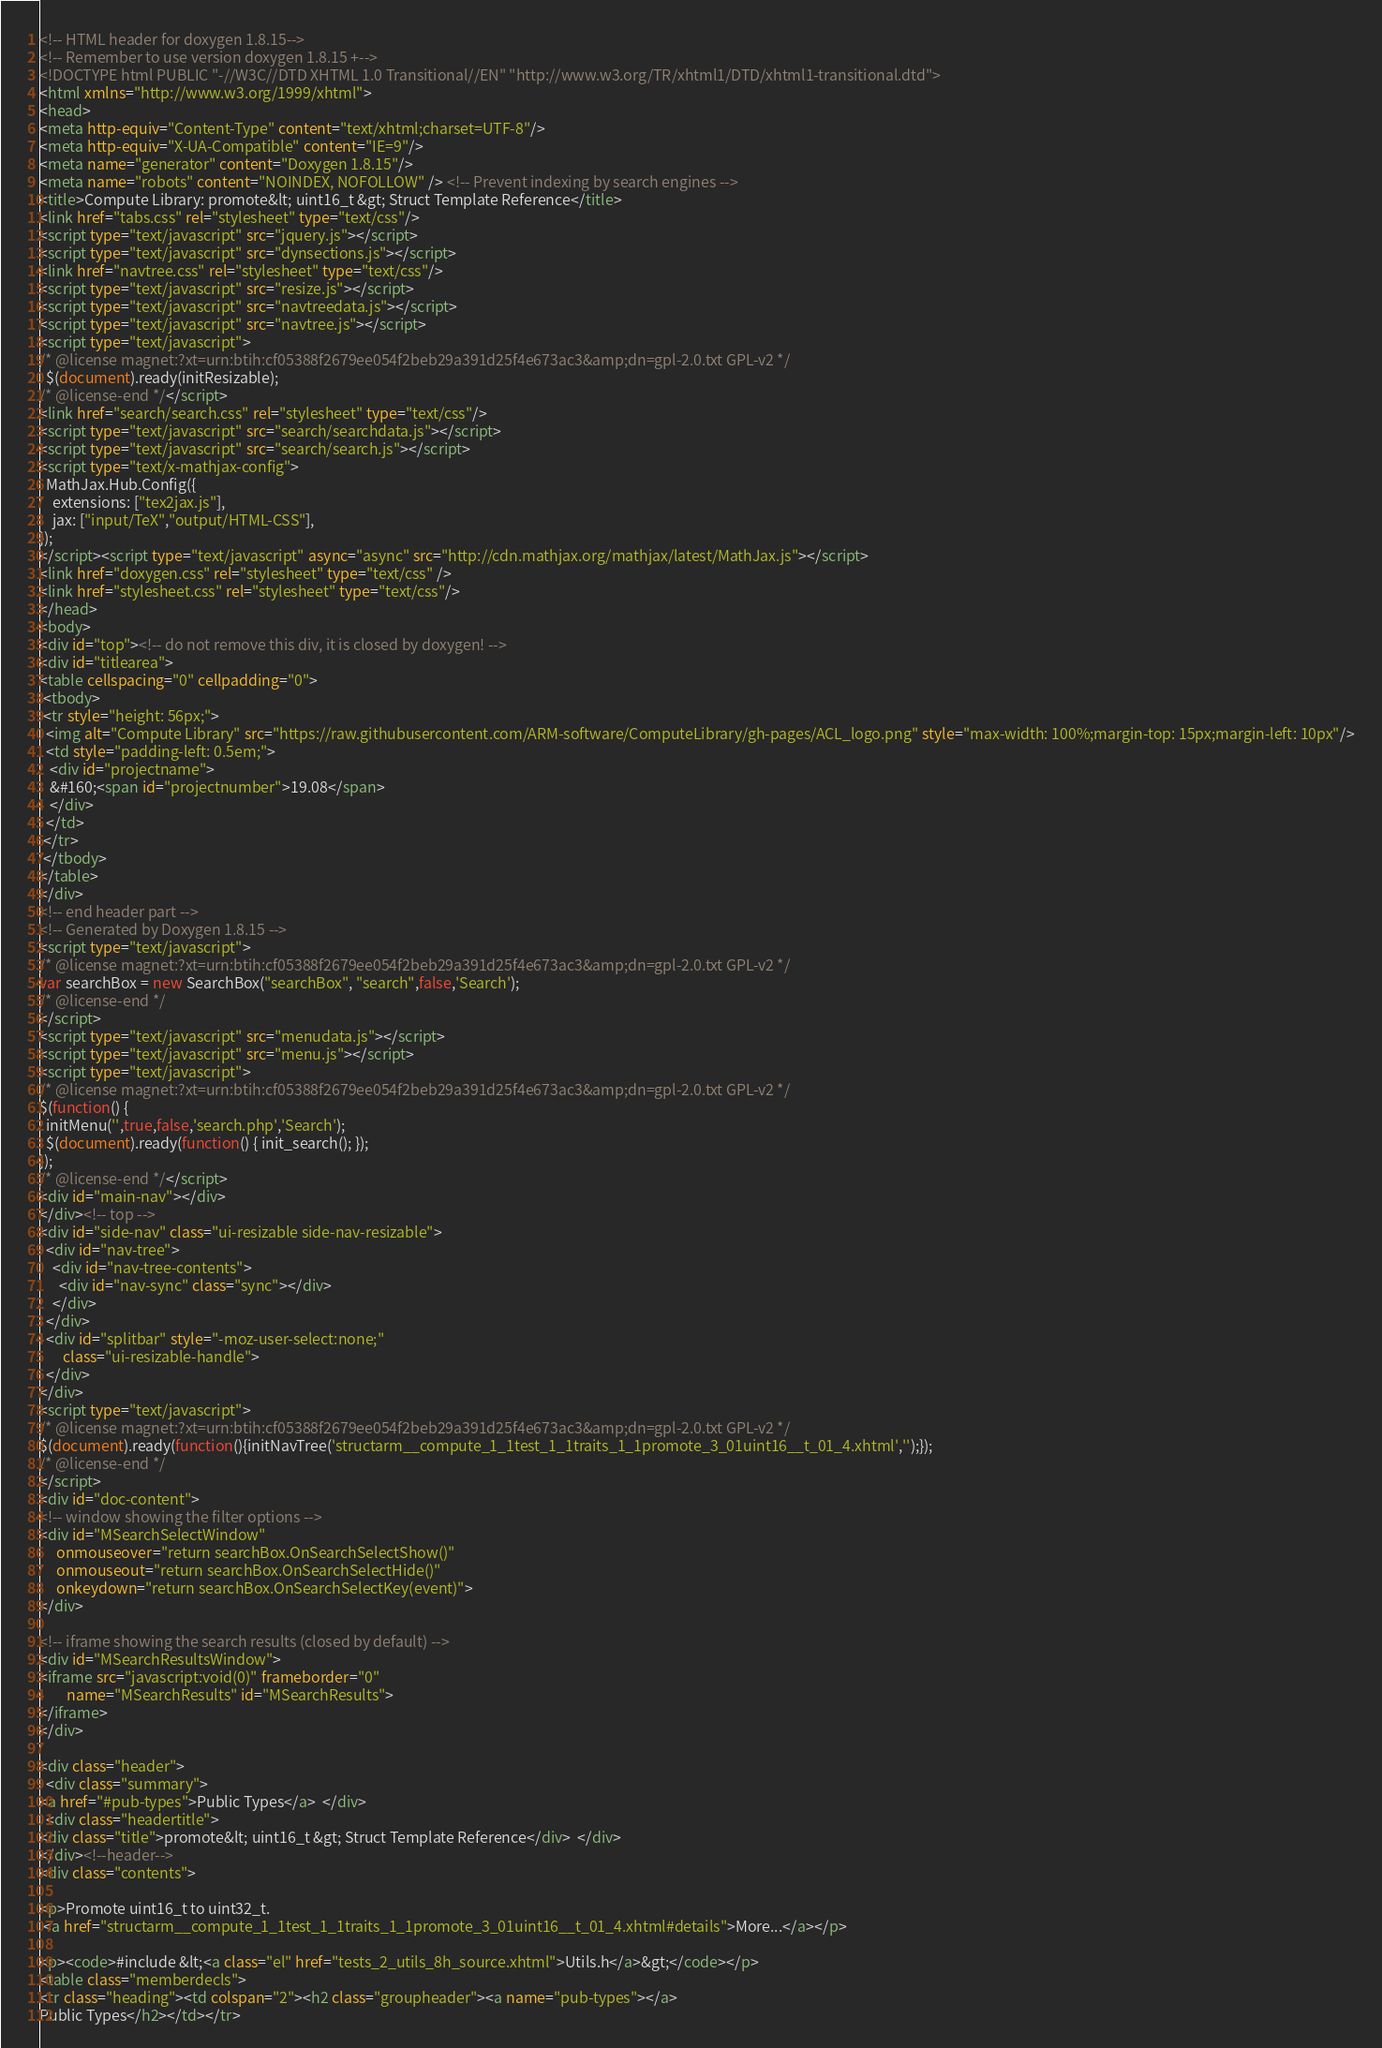<code> <loc_0><loc_0><loc_500><loc_500><_HTML_><!-- HTML header for doxygen 1.8.15-->
<!-- Remember to use version doxygen 1.8.15 +-->
<!DOCTYPE html PUBLIC "-//W3C//DTD XHTML 1.0 Transitional//EN" "http://www.w3.org/TR/xhtml1/DTD/xhtml1-transitional.dtd">
<html xmlns="http://www.w3.org/1999/xhtml">
<head>
<meta http-equiv="Content-Type" content="text/xhtml;charset=UTF-8"/>
<meta http-equiv="X-UA-Compatible" content="IE=9"/>
<meta name="generator" content="Doxygen 1.8.15"/>
<meta name="robots" content="NOINDEX, NOFOLLOW" /> <!-- Prevent indexing by search engines -->
<title>Compute Library: promote&lt; uint16_t &gt; Struct Template Reference</title>
<link href="tabs.css" rel="stylesheet" type="text/css"/>
<script type="text/javascript" src="jquery.js"></script>
<script type="text/javascript" src="dynsections.js"></script>
<link href="navtree.css" rel="stylesheet" type="text/css"/>
<script type="text/javascript" src="resize.js"></script>
<script type="text/javascript" src="navtreedata.js"></script>
<script type="text/javascript" src="navtree.js"></script>
<script type="text/javascript">
/* @license magnet:?xt=urn:btih:cf05388f2679ee054f2beb29a391d25f4e673ac3&amp;dn=gpl-2.0.txt GPL-v2 */
  $(document).ready(initResizable);
/* @license-end */</script>
<link href="search/search.css" rel="stylesheet" type="text/css"/>
<script type="text/javascript" src="search/searchdata.js"></script>
<script type="text/javascript" src="search/search.js"></script>
<script type="text/x-mathjax-config">
  MathJax.Hub.Config({
    extensions: ["tex2jax.js"],
    jax: ["input/TeX","output/HTML-CSS"],
});
</script><script type="text/javascript" async="async" src="http://cdn.mathjax.org/mathjax/latest/MathJax.js"></script>
<link href="doxygen.css" rel="stylesheet" type="text/css" />
<link href="stylesheet.css" rel="stylesheet" type="text/css"/>
</head>
<body>
<div id="top"><!-- do not remove this div, it is closed by doxygen! -->
<div id="titlearea">
<table cellspacing="0" cellpadding="0">
 <tbody>
 <tr style="height: 56px;">
  <img alt="Compute Library" src="https://raw.githubusercontent.com/ARM-software/ComputeLibrary/gh-pages/ACL_logo.png" style="max-width: 100%;margin-top: 15px;margin-left: 10px"/>
  <td style="padding-left: 0.5em;">
   <div id="projectname">
   &#160;<span id="projectnumber">19.08</span>
   </div>
  </td>
 </tr>
 </tbody>
</table>
</div>
<!-- end header part -->
<!-- Generated by Doxygen 1.8.15 -->
<script type="text/javascript">
/* @license magnet:?xt=urn:btih:cf05388f2679ee054f2beb29a391d25f4e673ac3&amp;dn=gpl-2.0.txt GPL-v2 */
var searchBox = new SearchBox("searchBox", "search",false,'Search');
/* @license-end */
</script>
<script type="text/javascript" src="menudata.js"></script>
<script type="text/javascript" src="menu.js"></script>
<script type="text/javascript">
/* @license magnet:?xt=urn:btih:cf05388f2679ee054f2beb29a391d25f4e673ac3&amp;dn=gpl-2.0.txt GPL-v2 */
$(function() {
  initMenu('',true,false,'search.php','Search');
  $(document).ready(function() { init_search(); });
});
/* @license-end */</script>
<div id="main-nav"></div>
</div><!-- top -->
<div id="side-nav" class="ui-resizable side-nav-resizable">
  <div id="nav-tree">
    <div id="nav-tree-contents">
      <div id="nav-sync" class="sync"></div>
    </div>
  </div>
  <div id="splitbar" style="-moz-user-select:none;" 
       class="ui-resizable-handle">
  </div>
</div>
<script type="text/javascript">
/* @license magnet:?xt=urn:btih:cf05388f2679ee054f2beb29a391d25f4e673ac3&amp;dn=gpl-2.0.txt GPL-v2 */
$(document).ready(function(){initNavTree('structarm__compute_1_1test_1_1traits_1_1promote_3_01uint16__t_01_4.xhtml','');});
/* @license-end */
</script>
<div id="doc-content">
<!-- window showing the filter options -->
<div id="MSearchSelectWindow"
     onmouseover="return searchBox.OnSearchSelectShow()"
     onmouseout="return searchBox.OnSearchSelectHide()"
     onkeydown="return searchBox.OnSearchSelectKey(event)">
</div>

<!-- iframe showing the search results (closed by default) -->
<div id="MSearchResultsWindow">
<iframe src="javascript:void(0)" frameborder="0" 
        name="MSearchResults" id="MSearchResults">
</iframe>
</div>

<div class="header">
  <div class="summary">
<a href="#pub-types">Public Types</a>  </div>
  <div class="headertitle">
<div class="title">promote&lt; uint16_t &gt; Struct Template Reference</div>  </div>
</div><!--header-->
<div class="contents">

<p>Promote uint16_t to uint32_t.  
 <a href="structarm__compute_1_1test_1_1traits_1_1promote_3_01uint16__t_01_4.xhtml#details">More...</a></p>

<p><code>#include &lt;<a class="el" href="tests_2_utils_8h_source.xhtml">Utils.h</a>&gt;</code></p>
<table class="memberdecls">
<tr class="heading"><td colspan="2"><h2 class="groupheader"><a name="pub-types"></a>
Public Types</h2></td></tr></code> 